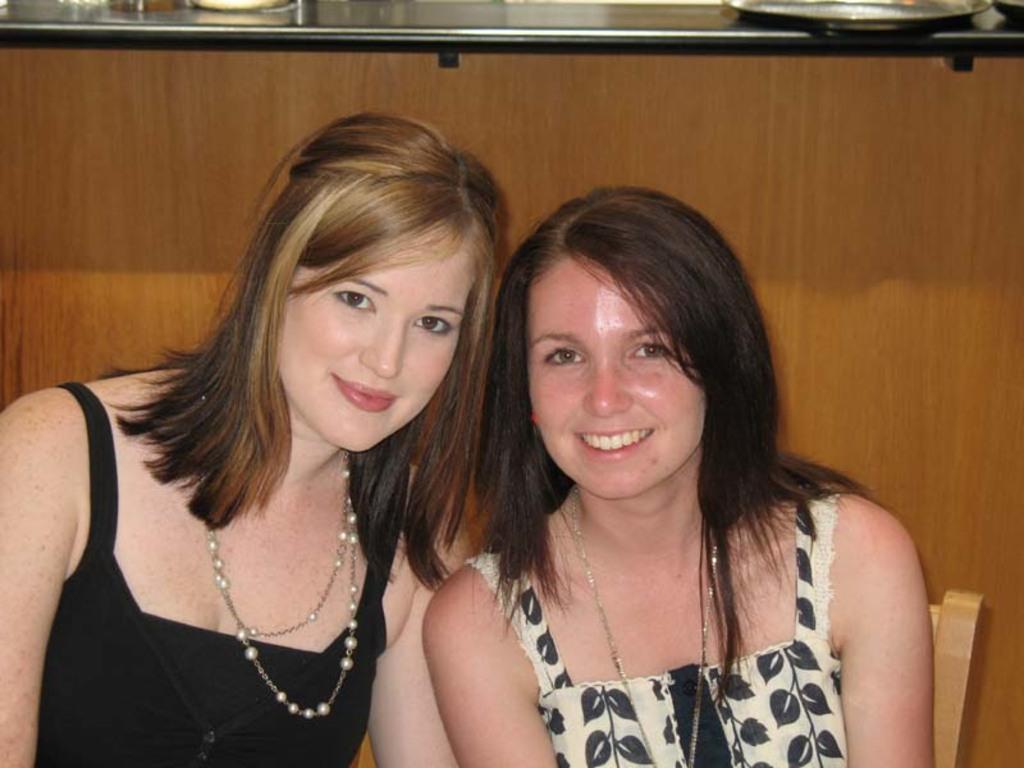Could you give a brief overview of what you see in this image? There are two ladies. Both are wearing chain and smiling. In the back there is a wooden wall with a platform. 